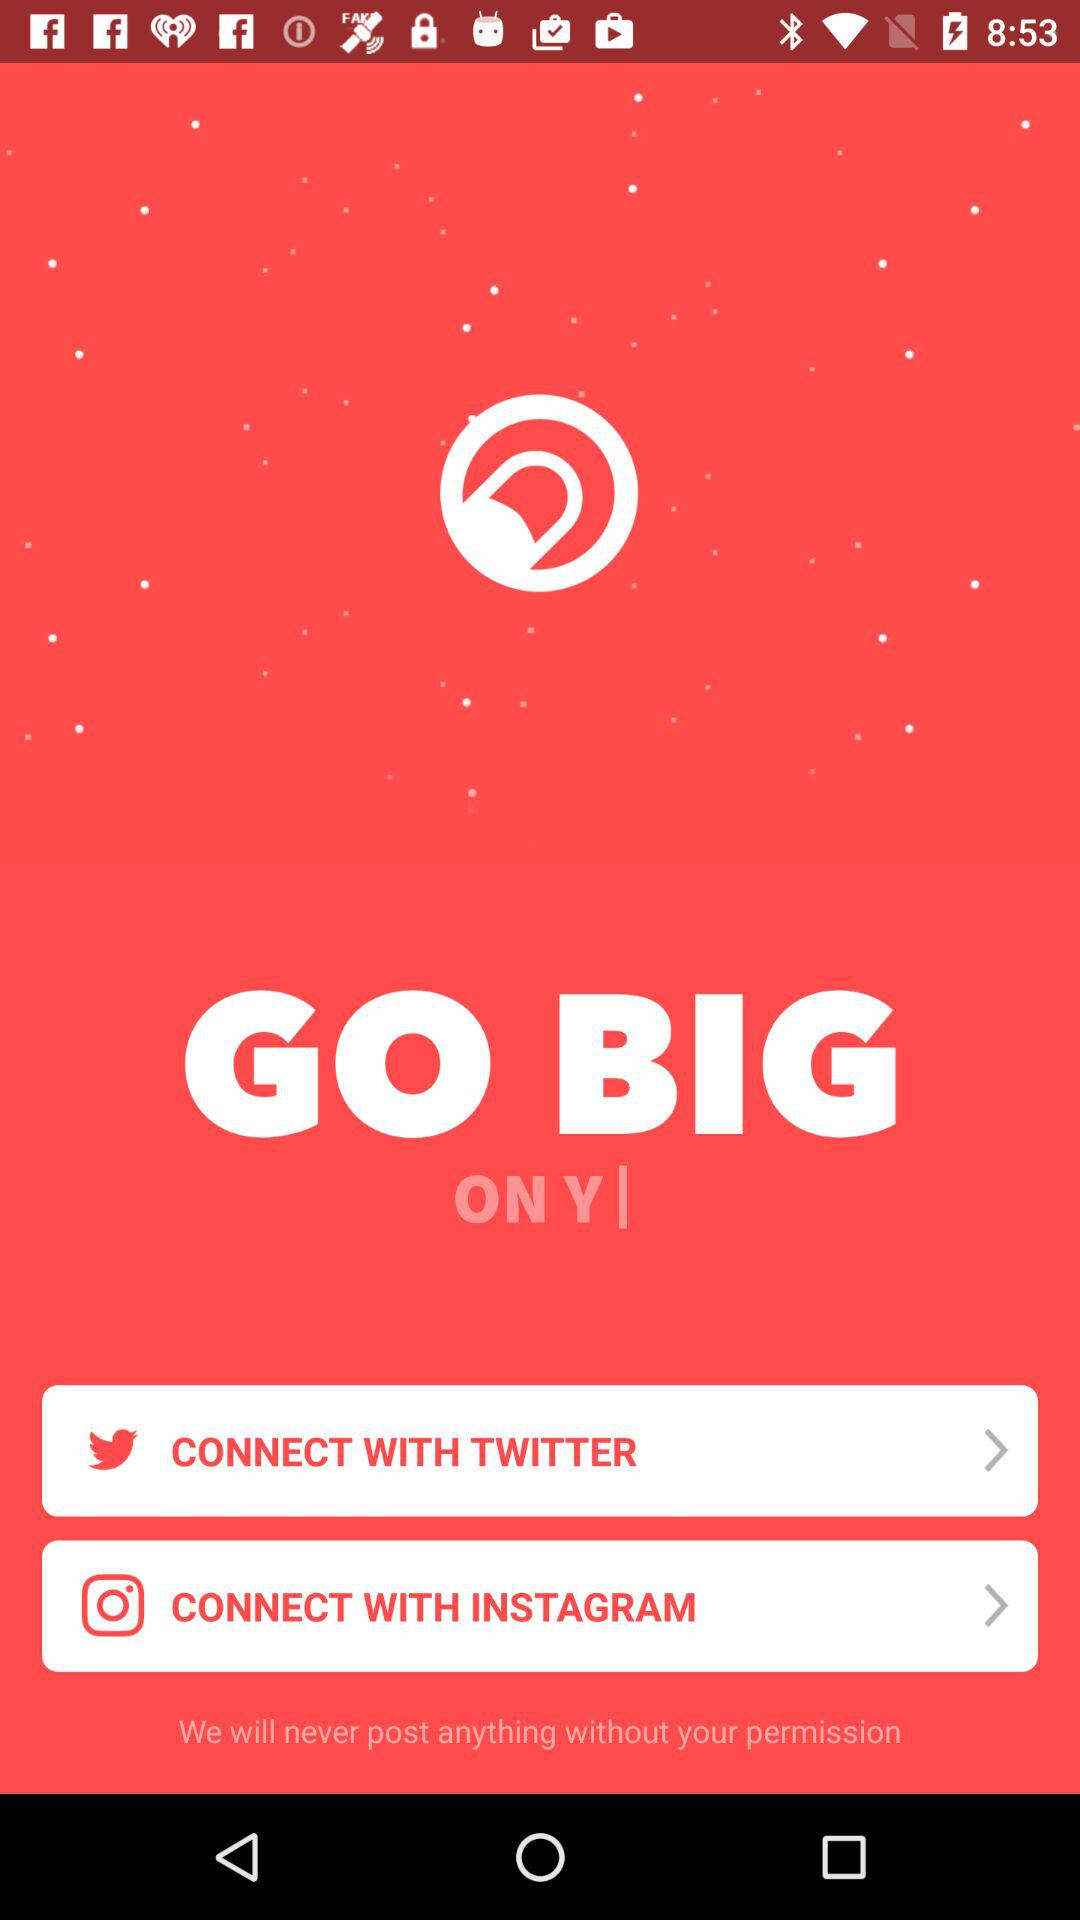Which application can the user connect with? The user can connect with "TWITTER" and "INSTAGRAM" applications. 